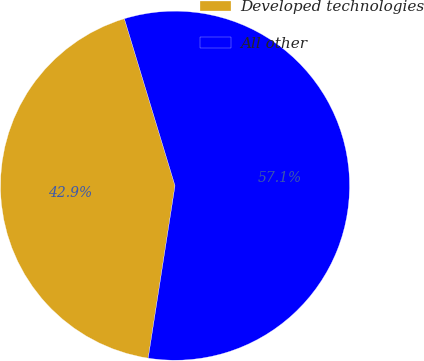<chart> <loc_0><loc_0><loc_500><loc_500><pie_chart><fcel>Developed technologies<fcel>All other<nl><fcel>42.86%<fcel>57.14%<nl></chart> 